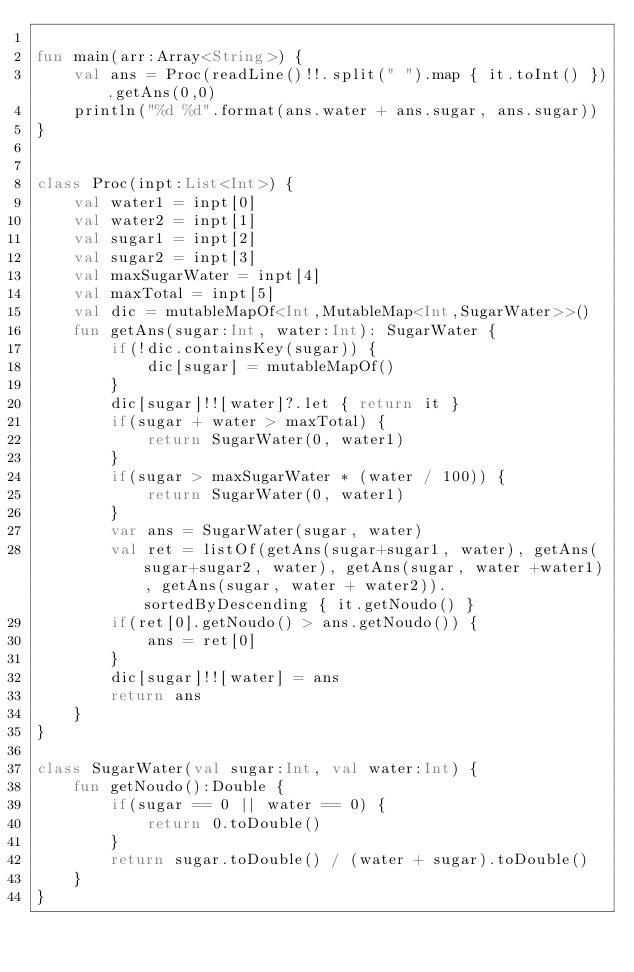<code> <loc_0><loc_0><loc_500><loc_500><_Kotlin_>
fun main(arr:Array<String>) {
    val ans = Proc(readLine()!!.split(" ").map { it.toInt() }).getAns(0,0)
    println("%d %d".format(ans.water + ans.sugar, ans.sugar))
}


class Proc(inpt:List<Int>) {
    val water1 = inpt[0]
    val water2 = inpt[1]
    val sugar1 = inpt[2]
    val sugar2 = inpt[3]
    val maxSugarWater = inpt[4]
    val maxTotal = inpt[5]
    val dic = mutableMapOf<Int,MutableMap<Int,SugarWater>>()
    fun getAns(sugar:Int, water:Int): SugarWater {
        if(!dic.containsKey(sugar)) {
            dic[sugar] = mutableMapOf()
        }
        dic[sugar]!![water]?.let { return it }
        if(sugar + water > maxTotal) {
            return SugarWater(0, water1)
        }
        if(sugar > maxSugarWater * (water / 100)) {
            return SugarWater(0, water1)
        }
        var ans = SugarWater(sugar, water)
        val ret = listOf(getAns(sugar+sugar1, water), getAns(sugar+sugar2, water), getAns(sugar, water +water1), getAns(sugar, water + water2)).sortedByDescending { it.getNoudo() }
        if(ret[0].getNoudo() > ans.getNoudo()) {
            ans = ret[0]
        }
        dic[sugar]!![water] = ans
        return ans
    }
}

class SugarWater(val sugar:Int, val water:Int) {
    fun getNoudo():Double {
        if(sugar == 0 || water == 0) {
            return 0.toDouble()
        }
        return sugar.toDouble() / (water + sugar).toDouble()
    }
}
</code> 